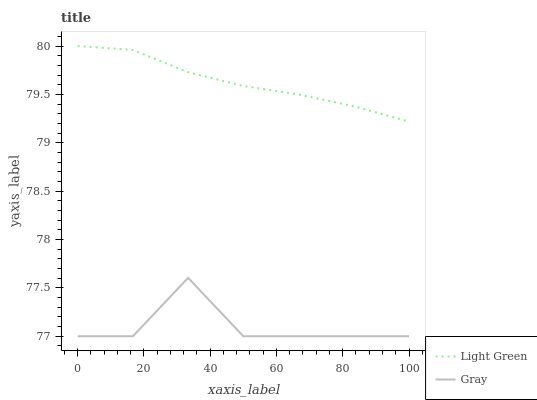Does Light Green have the minimum area under the curve?
Answer yes or no. No. Is Light Green the roughest?
Answer yes or no. No. Does Light Green have the lowest value?
Answer yes or no. No. Is Gray less than Light Green?
Answer yes or no. Yes. Is Light Green greater than Gray?
Answer yes or no. Yes. Does Gray intersect Light Green?
Answer yes or no. No. 